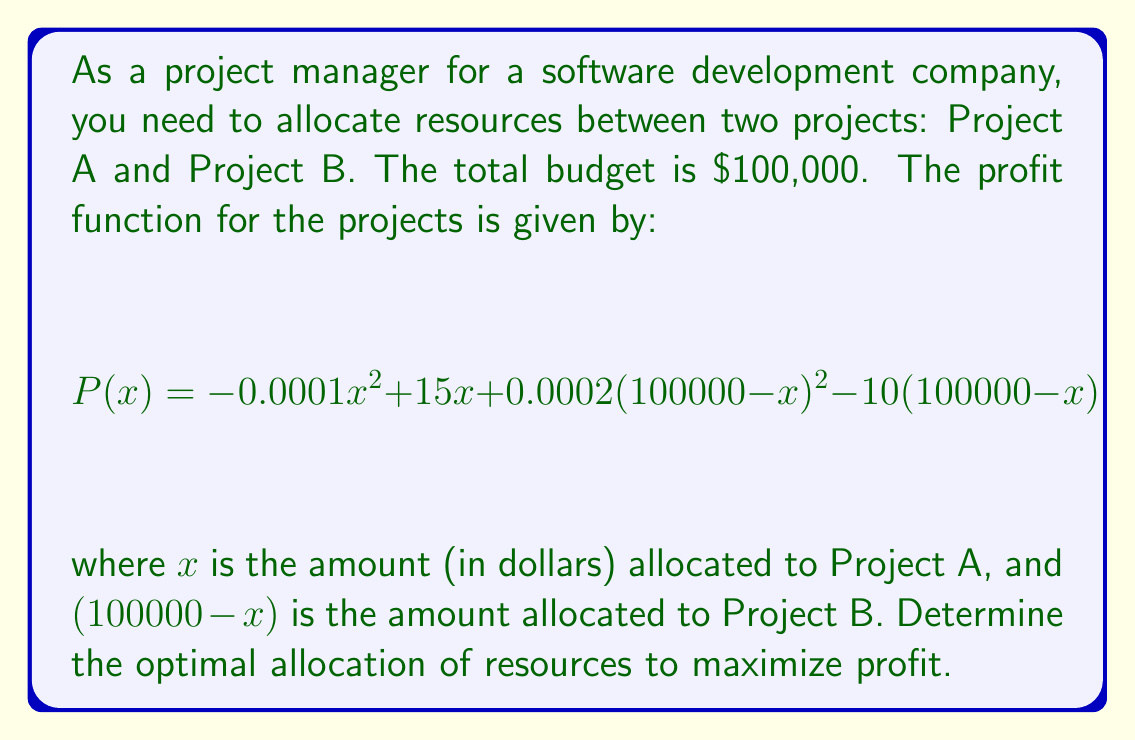Solve this math problem. To find the optimal allocation, we need to maximize the profit function P(x). This can be done by finding the critical point where the derivative of P(x) equals zero.

Step 1: Calculate the derivative of P(x).
$$P'(x) = -0.0002x + 15 - 0.0004(100000-x) + 10$$
$$P'(x) = -0.0002x + 15 - 40 + 0.0004x + 10$$
$$P'(x) = 0.0002x - 15$$

Step 2: Set the derivative equal to zero and solve for x.
$$0.0002x - 15 = 0$$
$$0.0002x = 15$$
$$x = 75000$$

Step 3: Verify that this critical point is a maximum by checking the second derivative.
$$P''(x) = 0.0002 > 0$$
Since the second derivative is positive, this critical point is a local minimum. However, since our function is a quadratic and we're working within a constrained domain (0 ≤ x ≤ 100000), this point represents the global maximum.

Step 4: Calculate the allocation for Project B.
Project B allocation = 100000 - 75000 = 25000

Step 5: Verify the result by plugging the values back into the original profit function.
$$P(75000) = -0.0001(75000)^2 + 15(75000) + 0.0002(25000)^2 - 10(25000)$$
$$= -562500 + 1125000 + 125000 - 250000 = 437500$$

This confirms that allocating $75,000 to Project A and $25,000 to Project B maximizes the profit.
Answer: Allocate $75,000 to Project A and $25,000 to Project B. 